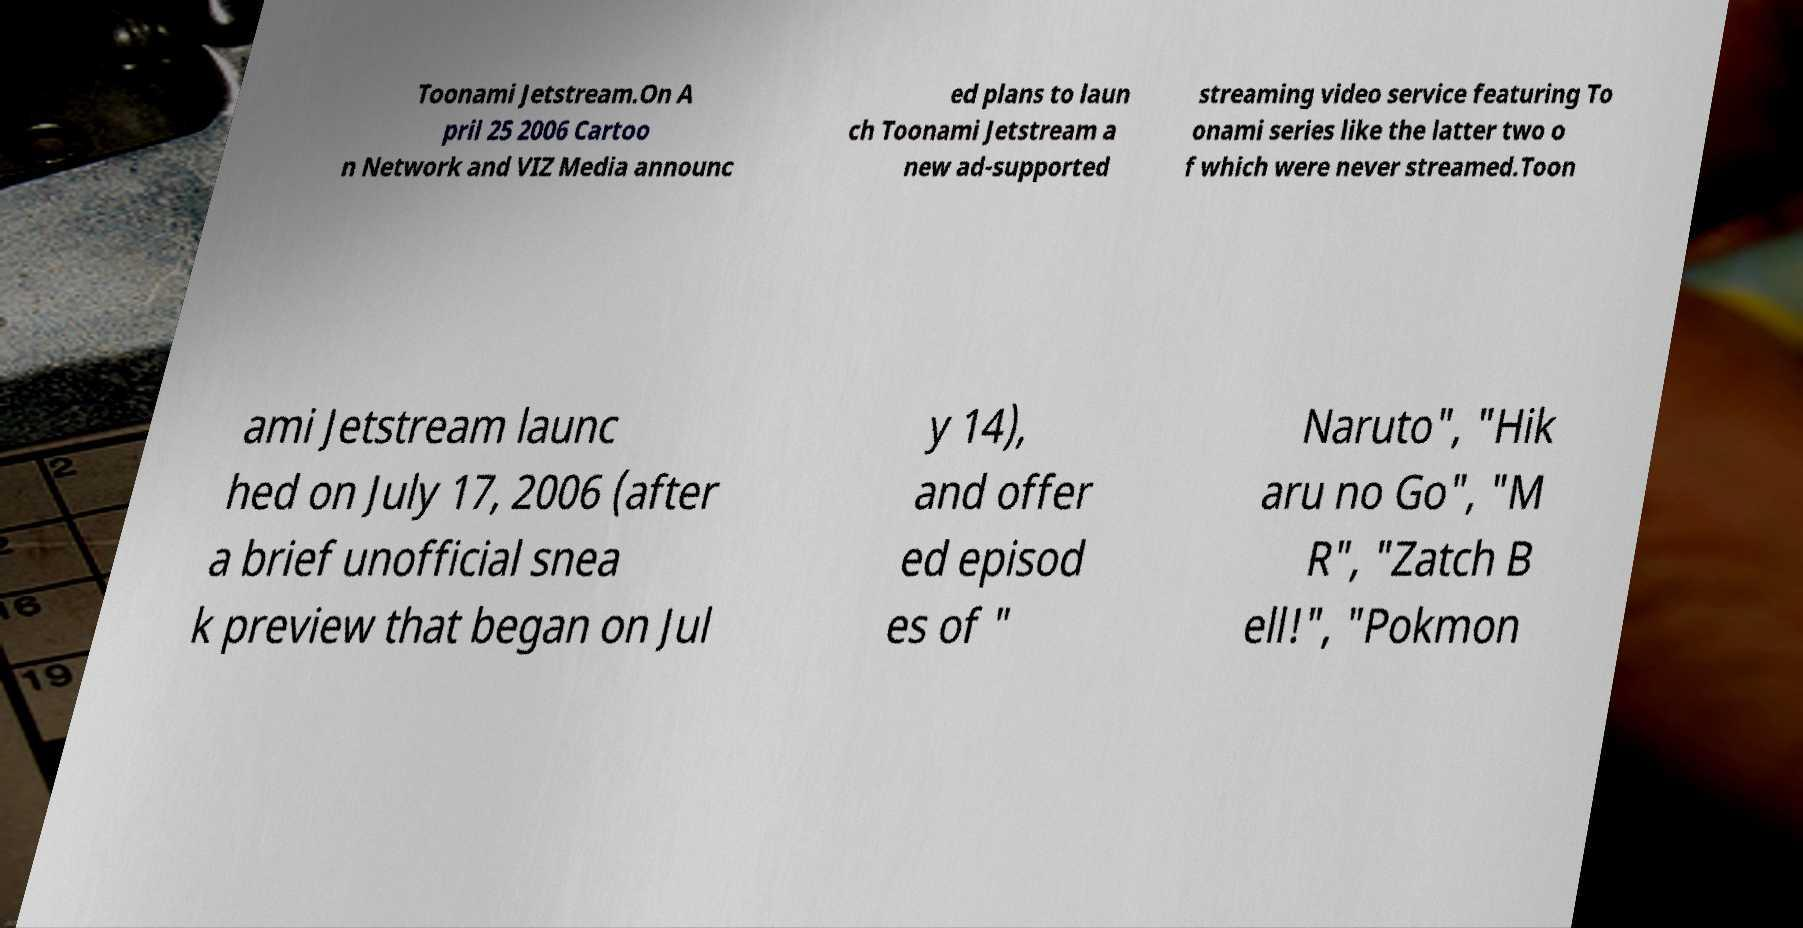For documentation purposes, I need the text within this image transcribed. Could you provide that? Toonami Jetstream.On A pril 25 2006 Cartoo n Network and VIZ Media announc ed plans to laun ch Toonami Jetstream a new ad-supported streaming video service featuring To onami series like the latter two o f which were never streamed.Toon ami Jetstream launc hed on July 17, 2006 (after a brief unofficial snea k preview that began on Jul y 14), and offer ed episod es of " Naruto", "Hik aru no Go", "M R", "Zatch B ell!", "Pokmon 